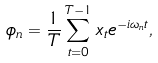Convert formula to latex. <formula><loc_0><loc_0><loc_500><loc_500>\phi _ { n } = \frac { 1 } { T } \sum _ { t = 0 } ^ { T - 1 } x _ { t } e ^ { - i \omega _ { n } t } ,</formula> 